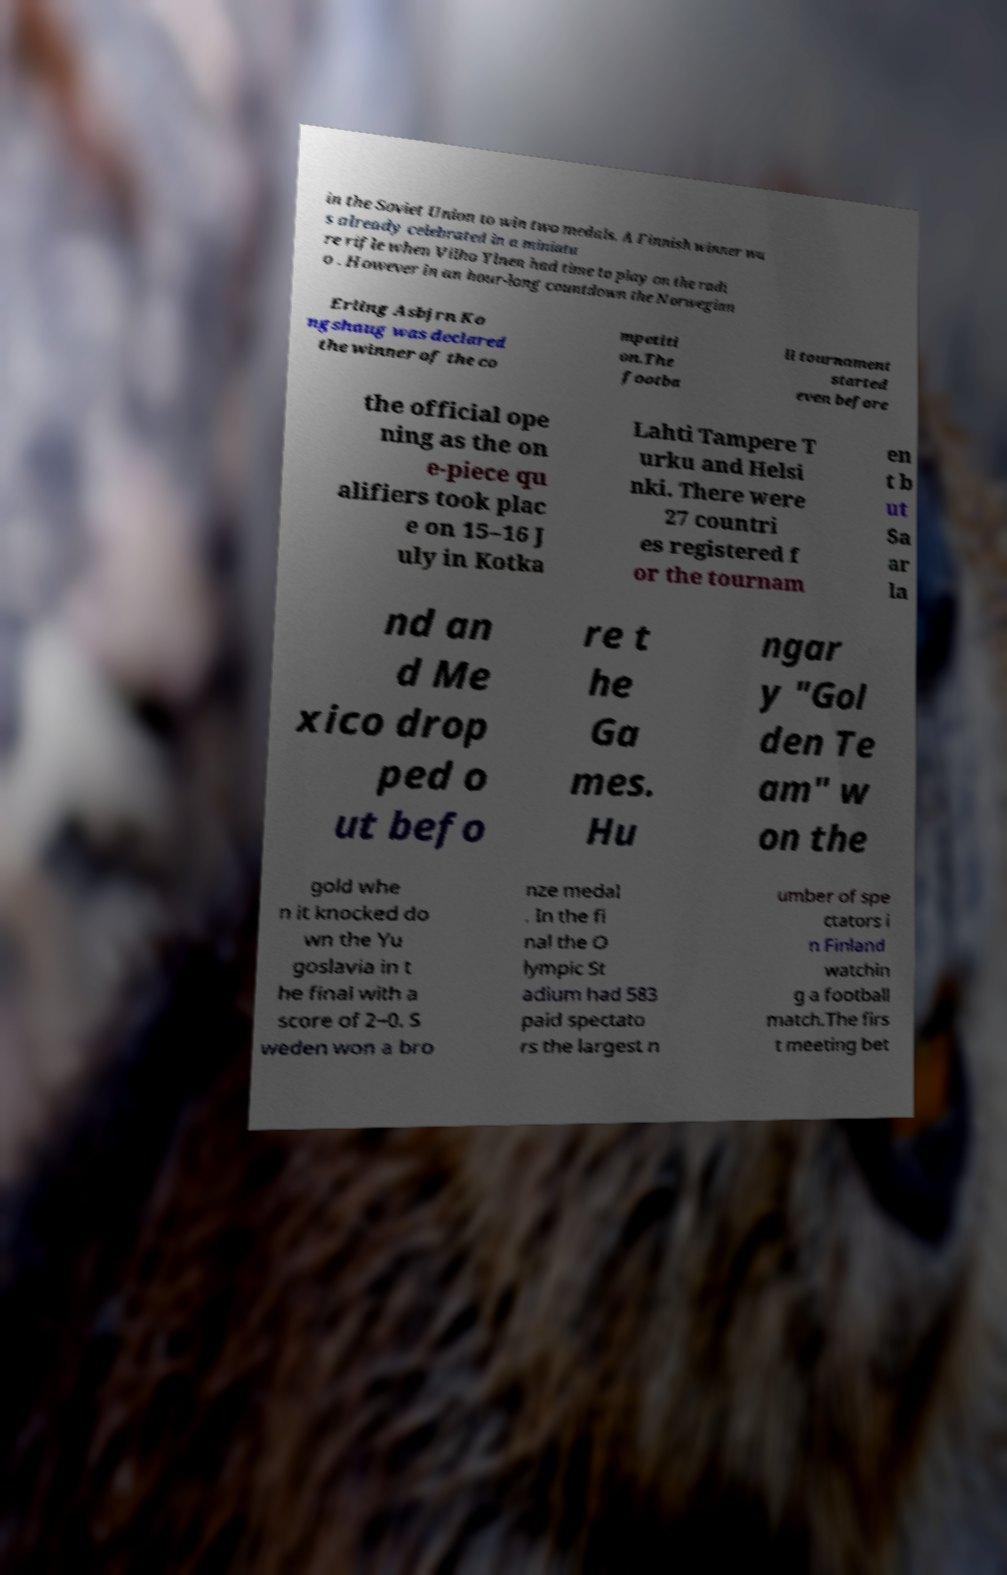Can you accurately transcribe the text from the provided image for me? in the Soviet Union to win two medals. A Finnish winner wa s already celebrated in a miniatu re rifle when Vilho Ylnen had time to play on the radi o . However in an hour-long countdown the Norwegian Erling Asbjrn Ko ngshaug was declared the winner of the co mpetiti on.The footba ll tournament started even before the official ope ning as the on e-piece qu alifiers took plac e on 15–16 J uly in Kotka Lahti Tampere T urku and Helsi nki. There were 27 countri es registered f or the tournam en t b ut Sa ar la nd an d Me xico drop ped o ut befo re t he Ga mes. Hu ngar y "Gol den Te am" w on the gold whe n it knocked do wn the Yu goslavia in t he final with a score of 2–0. S weden won a bro nze medal . In the fi nal the O lympic St adium had 583 paid spectato rs the largest n umber of spe ctators i n Finland watchin g a football match.The firs t meeting bet 